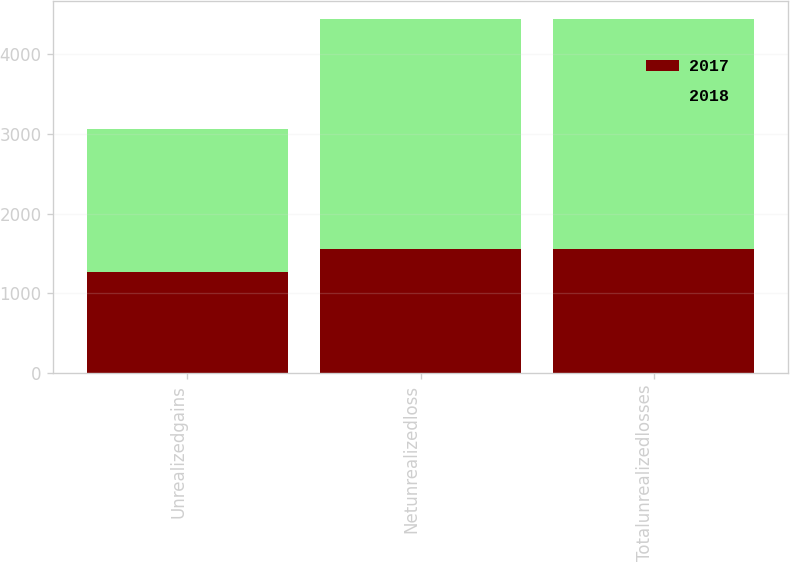<chart> <loc_0><loc_0><loc_500><loc_500><stacked_bar_chart><ecel><fcel>Unrealizedgains<fcel>Netunrealizedloss<fcel>Totalunrealizedlosses<nl><fcel>2017<fcel>1269<fcel>1551<fcel>1551<nl><fcel>2018<fcel>1793<fcel>2891<fcel>2891<nl></chart> 